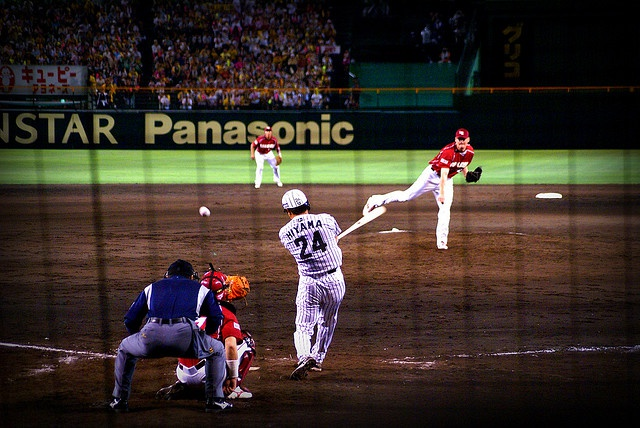Describe the objects in this image and their specific colors. I can see people in black, maroon, navy, and gray tones, people in black, navy, and purple tones, people in black, lavender, and violet tones, people in black, maroon, brown, and lightgray tones, and people in black, white, brown, maroon, and red tones in this image. 